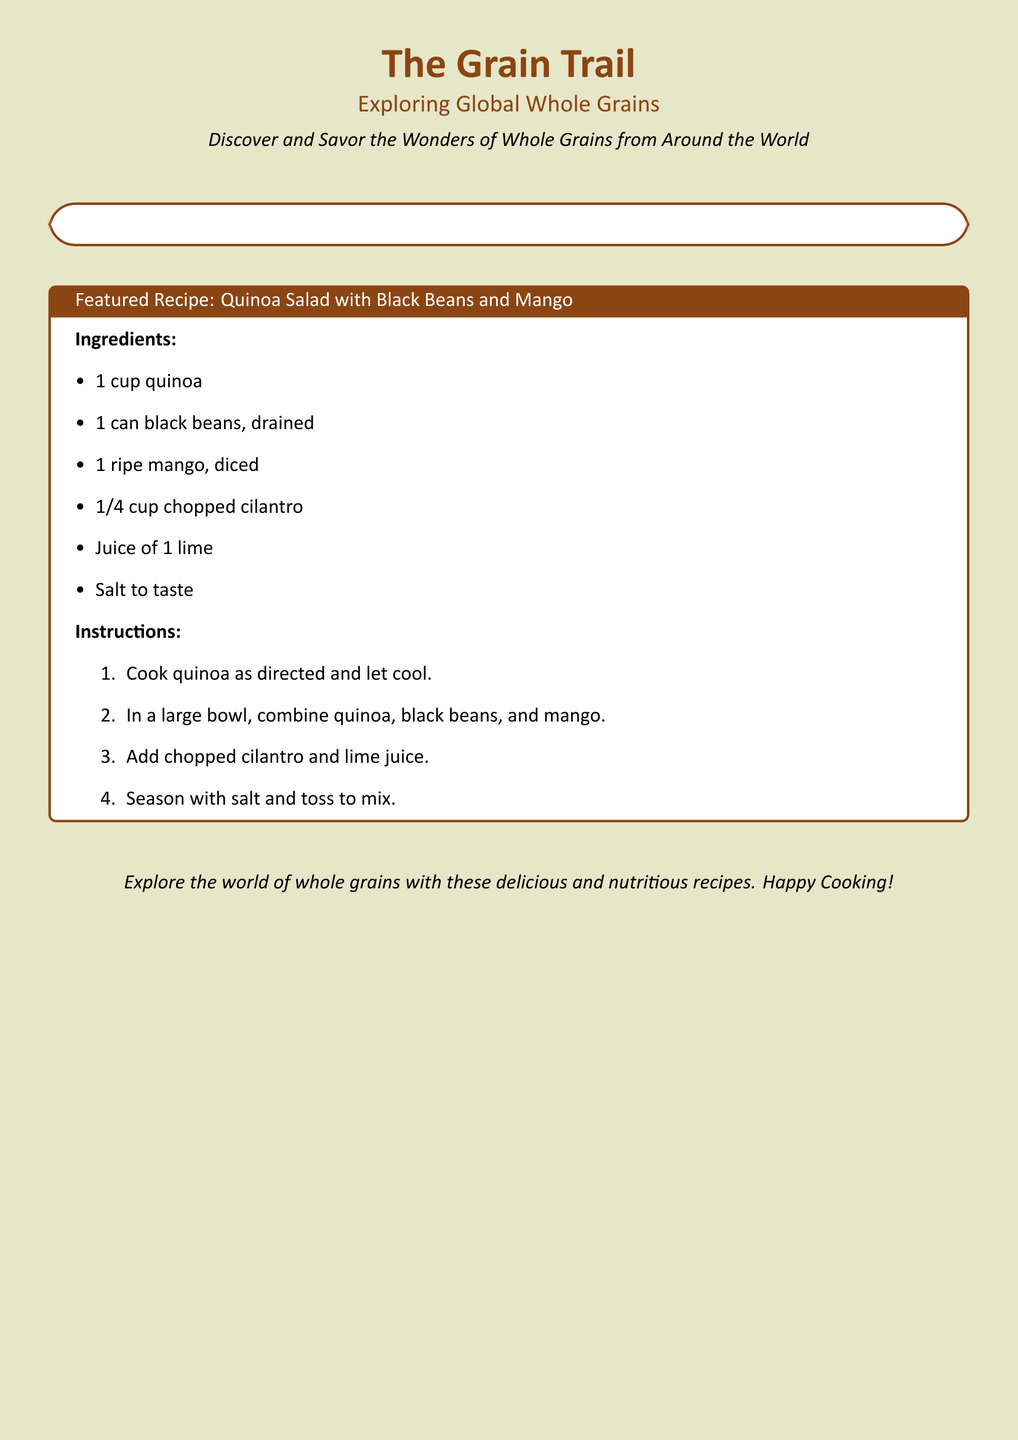What is the title of the card? The title is prominently displayed at the top of the card.
Answer: The Grain Trail What is the main theme of the card? The theme is indicated in the subtitle underneath the title.
Answer: Exploring Global Whole Grains How many grains are featured in the document? The grains are listed in a table-like format, specifically noted in the boxes.
Answer: Six What is the cooking time for quinoa? The cooking time is given next to the quinoa listing in the document.
Answer: 15 min What unique ingredient is included in the featured recipe? The ingredient list specifies items unique to the recipe.
Answer: Mango Which grain is described as gluten-free? The information about the grains includes descriptions of each type.
Answer: Sorghum What is the water-to-quinoa ratio for cooking? The water ratio is provided in the cooking instructions for quinoa.
Answer: 2:1 How long should barley be cooked? The cooking instructions specify the time for barley.
Answer: 45 min What recipe is featured on the card? The title of the recipe is indicated within the tcolorbox.
Answer: Quinoa Salad with Black Beans and Mango 